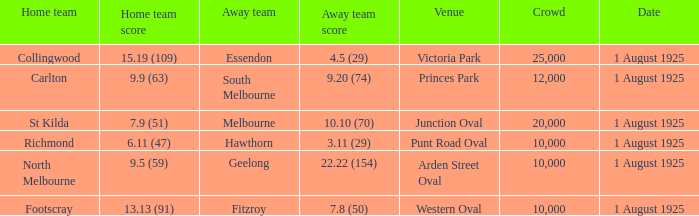Could you help me parse every detail presented in this table? {'header': ['Home team', 'Home team score', 'Away team', 'Away team score', 'Venue', 'Crowd', 'Date'], 'rows': [['Collingwood', '15.19 (109)', 'Essendon', '4.5 (29)', 'Victoria Park', '25,000', '1 August 1925'], ['Carlton', '9.9 (63)', 'South Melbourne', '9.20 (74)', 'Princes Park', '12,000', '1 August 1925'], ['St Kilda', '7.9 (51)', 'Melbourne', '10.10 (70)', 'Junction Oval', '20,000', '1 August 1925'], ['Richmond', '6.11 (47)', 'Hawthorn', '3.11 (29)', 'Punt Road Oval', '10,000', '1 August 1925'], ['North Melbourne', '9.5 (59)', 'Geelong', '22.22 (154)', 'Arden Street Oval', '10,000', '1 August 1925'], ['Footscray', '13.13 (91)', 'Fitzroy', '7.8 (50)', 'Western Oval', '10,000', '1 August 1925']]} Of matches that had a home team score of 13.13 (91), which one had the largest crowd? 10000.0. 